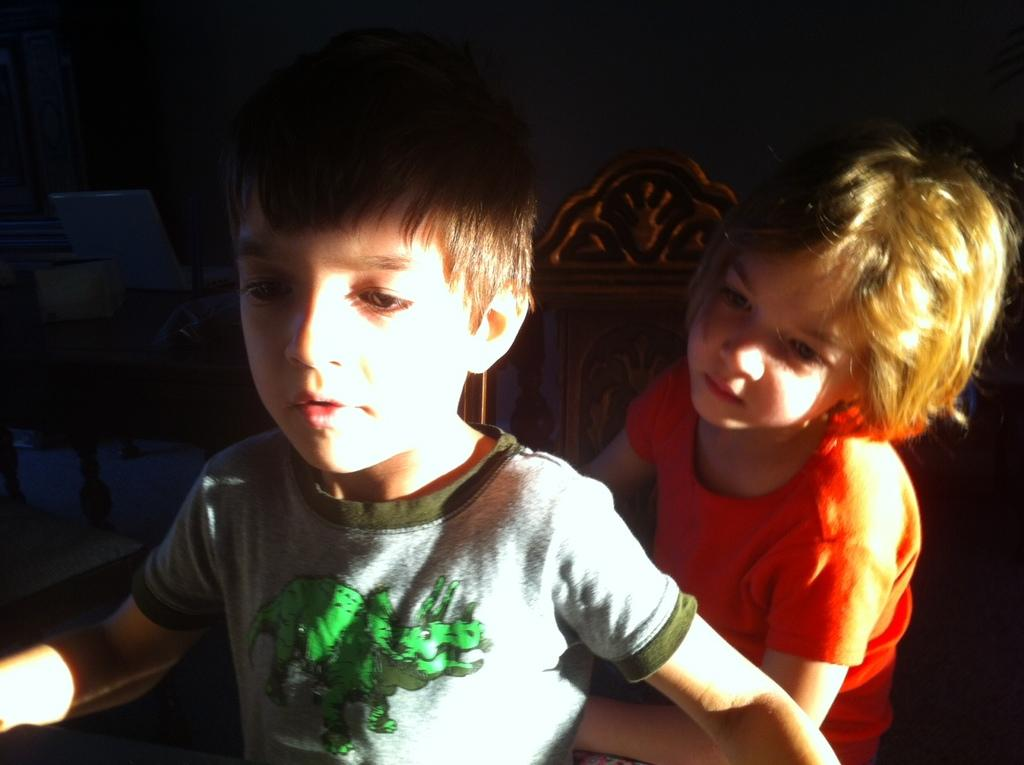How many children are in the image? There are two children in the image. What can be seen in the background of the image? There is a wooden object in the background of the image. What is the color of the background in the image? The background of the image is dark. What type of cord is being used by the children in the image? There is no cord visible in the image; the children are not using any cord. 